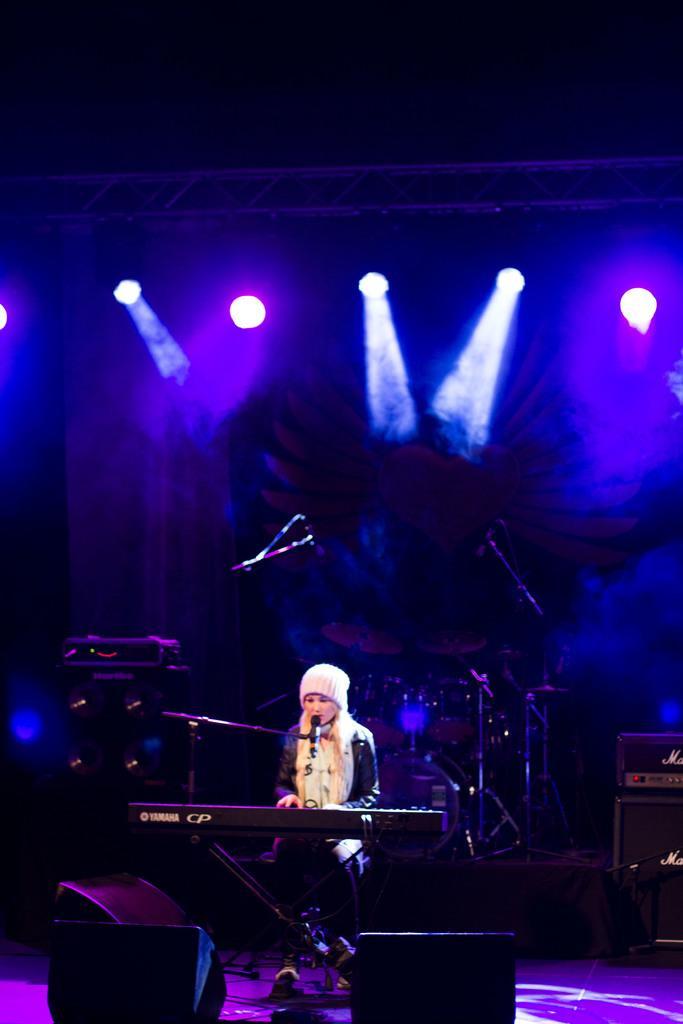Describe this image in one or two sentences. In the image there is a girl playing a piano and around her there are different music instruments, in the background there are different lights. 